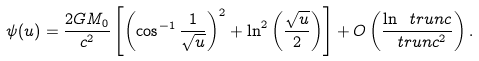<formula> <loc_0><loc_0><loc_500><loc_500>\psi ( u ) = \frac { 2 G M _ { 0 } } { c ^ { 2 } } \left [ \left ( \cos ^ { - 1 } \frac { 1 } { \sqrt { u } } \right ) ^ { 2 } + \ln ^ { 2 } \left ( \frac { \sqrt { u } } { 2 } \right ) \right ] + O \left ( \frac { \ln \ t r u n c } { \ t r u n c ^ { 2 } } \right ) .</formula> 